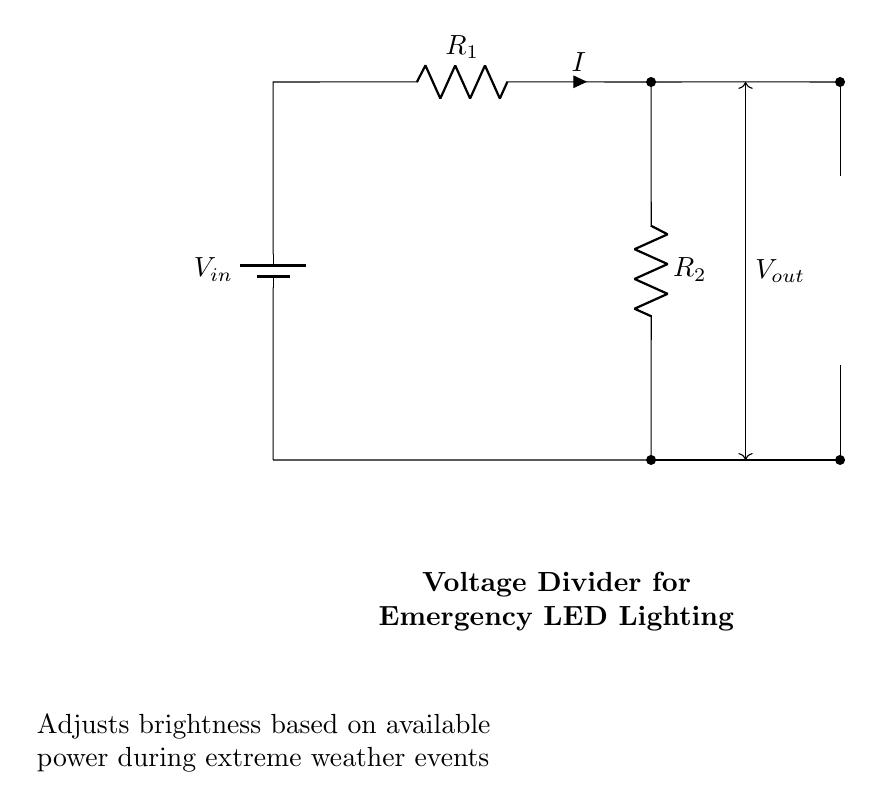What are the main components of this circuit? The circuit contains a battery, two resistors, and a LED. These components work together to adjust the brightness of the LED based on the voltage divider principle.
Answer: battery, resistors, LED What is the purpose of the resistors in this circuit? The resistors serve to create a voltage divider, which allows for controlling the amount of voltage that reaches the LED, thus adjusting its brightness based on the input voltage.
Answer: adjust brightness What voltage is applied to the LED in this circuit? The output voltage, which is the voltage after the resistors, is what is applied to the LED; it can be calculated using the voltage divider formula based on the values of the resistors and input voltage.
Answer: Vout What happens to the LED's brightness if R1 is increased? Increasing R1 would reduce the current flowing through the circuit, potentially resulting in a decrease in the brightness of the LED since less voltage would be available across it.
Answer: decreases What is the relationship between R1 and R2 in controlling brightness? The ratio of resistances R1 and R2 determines the division of voltage in the circuit; altering either resistance changes the voltage drop across the LED and thus its brightness.
Answer: voltage division ratio How can this circuit be beneficial during extreme weather events? By adjusting brightness based on available power, this circuit helps conserve energy and ensures the LED can operate under variable conditions that may arise during extreme weather.
Answer: energy conservation 